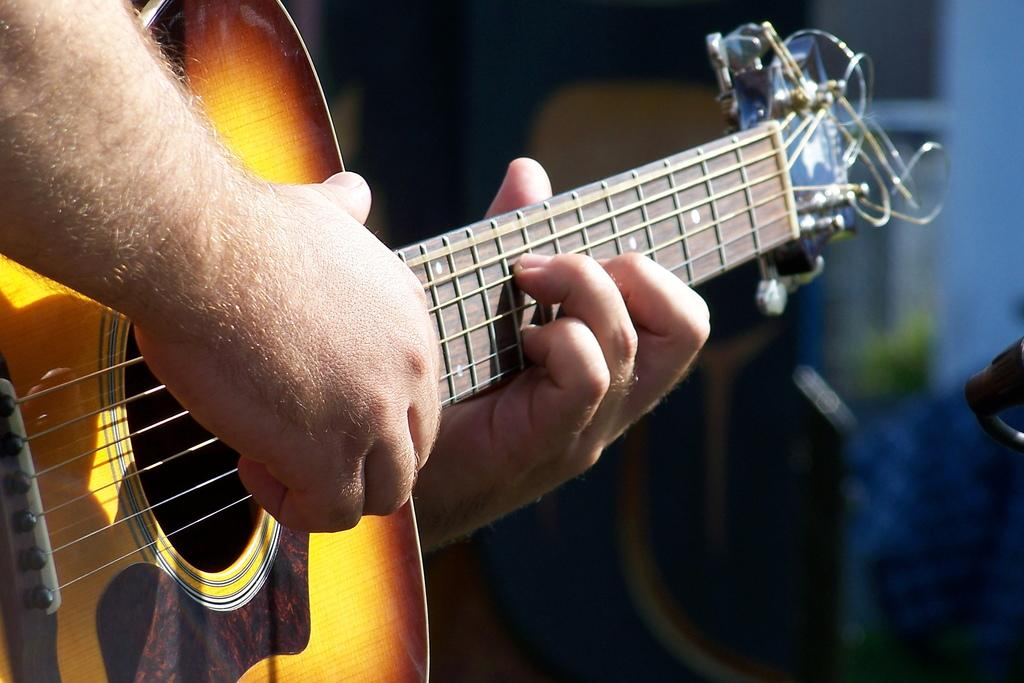What is the main subject of the image? There is a person in the image. What is the person doing in the image? The person is playing a guitar. How many cows can be seen in the image? There are no cows present in the image. What is the first step the person takes to start playing the guitar in the image? The image does not show the person taking any steps or starting to play the guitar; it only shows the person playing the guitar. 